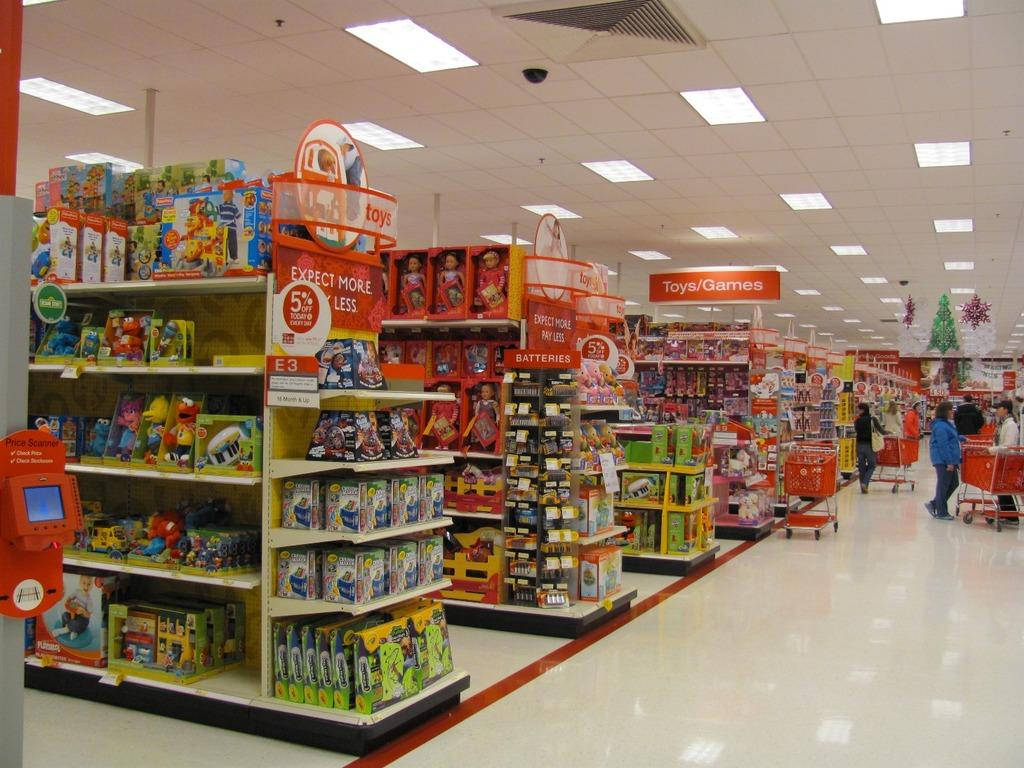<image>
Provide a brief description of the given image. The red sign on the isle says Expect More For Less 